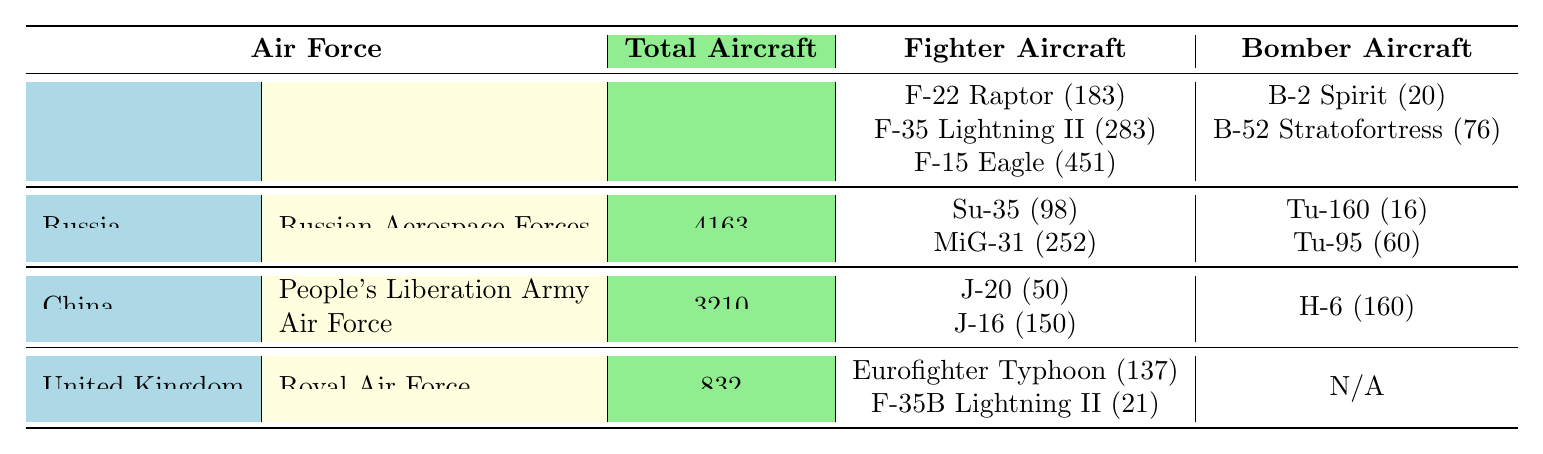What is the total number of aircraft in the United States Air Force? The table lists the total number of aircraft for each air force, and for the United States Air Force, it is clearly stated as 5217.
Answer: 5217 How many fighter aircraft does China have in its inventory? The table shows the fighter aircraft inventory for China under the People's Liberation Army Air Force, which includes J-20 and J-16 with inventories of 50 and 150 respectively, totaling 200.
Answer: 200 Which country has the highest number of total aircraft? By comparing the total aircraft across the countries in the table, the United States with 5217 has the highest total aircraft compared to Russia's 4163, China's 3210, and the United Kingdom's 832.
Answer: United States How many more fighter aircraft does the United States Air Force have compared to the Royal Air Force? The United States Air Force has 183 (F-22) + 283 (F-35) + 451 (F-15) = 917 fighter aircraft, while the Royal Air Force has 137 (Eurofighter) + 21 (F-35B) = 158 fighter aircraft. The difference is 917 - 158 = 759.
Answer: 759 Does the Russian Aerospace Forces have more bomber aircraft than the United Kingdom's Royal Air Force? The table shows that Russia has 16 (Tu-160) + 60 (Tu-95) = 76 bomber aircraft, while the United Kingdom has no bombers listed (N/A). Therefore, true, Russia has more bomber aircraft.
Answer: Yes What is the average number of fighter aircraft across the four air forces? The total fighter aircraft are 917 (US) + 350 (Russia) + 200 (China) + 158 (UK) = 1625. There are four air forces, so the average is 1625 / 4 = 406.25, rounded down to 406.
Answer: 406 Which air force operates the F-35 Lightning II aircraft? The table mentions that both the United States Air Force (F-35 Lightning II) and the Royal Air Force (F-35B Lightning II) have this aircraft in their inventory.
Answer: United States Air Force and Royal Air Force What is the total combat range of all bomber aircraft in the United States Air Force? The combat ranges for the bombers in the United States Air Force are 11,000 km (B-2 Spirit) and 14,080 km (B-52 Stratofortress), totaling 11,000 + 14,080 = 25,080 km.
Answer: 25,080 km How many fighter aircraft does Russia have in comparison to the total number of aircraft in China? Russia has 350 fighter aircraft (98 Su-35 and 252 MiG-31), while China has 3210 total aircraft. The comparison shows that Russia's fighter aircraft is significantly fewer.
Answer: 350 Which aircraft has the longest combat range in the bomber category across all listed air forces? The longest combat range from the bomber categories listed in the table is held by the B-52 Stratofortress of the United States Air Force with a combat range of 14,080 km.
Answer: B-52 Stratofortress What is the total number of aircraft in all four air forces combined? The total number is calculated by summing the totals: 5217 (US) + 4163 (Russia) + 3210 (China) + 832 (UK) = 13,422.
Answer: 13,422 